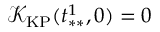Convert formula to latex. <formula><loc_0><loc_0><loc_500><loc_500>\mathcal { K } _ { K P } ( t _ { * * } ^ { 1 } , 0 ) = 0</formula> 